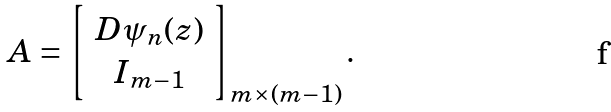Convert formula to latex. <formula><loc_0><loc_0><loc_500><loc_500>A = \left [ \begin{array} { c } D \psi _ { n } ( z ) \\ I _ { m - 1 } \end{array} \right ] _ { m \times ( m - 1 ) } .</formula> 